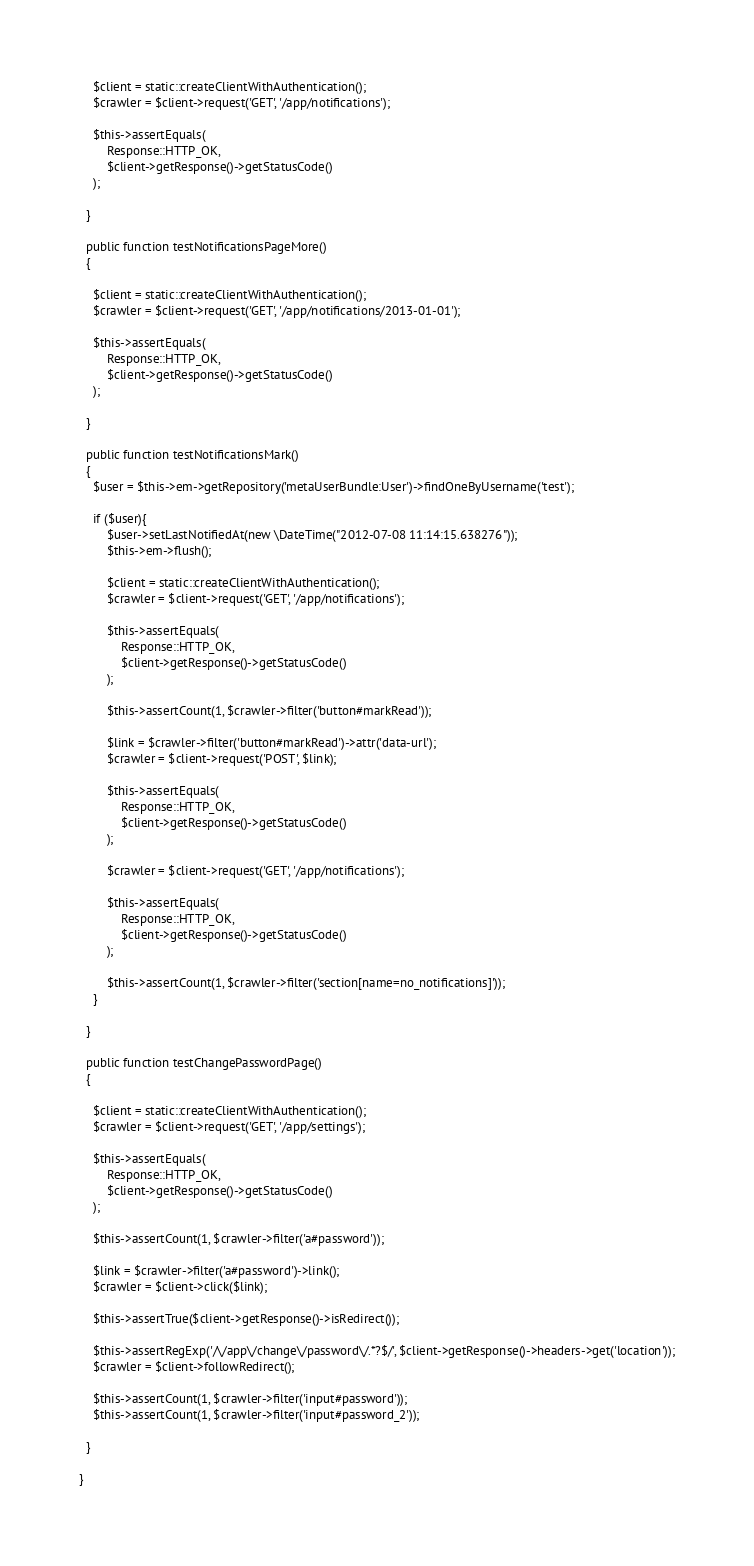<code> <loc_0><loc_0><loc_500><loc_500><_PHP_>
    $client = static::createClientWithAuthentication();
    $crawler = $client->request('GET', '/app/notifications');

    $this->assertEquals(
        Response::HTTP_OK,
        $client->getResponse()->getStatusCode()
    );
    
  }

  public function testNotificationsPageMore()
  {
   
    $client = static::createClientWithAuthentication();
    $crawler = $client->request('GET', '/app/notifications/2013-01-01');

    $this->assertEquals(
        Response::HTTP_OK,
        $client->getResponse()->getStatusCode()
    );

  }

  public function testNotificationsMark()
  {
    $user = $this->em->getRepository('metaUserBundle:User')->findOneByUsername('test');

    if ($user){
        $user->setLastNotifiedAt(new \DateTime("2012-07-08 11:14:15.638276"));
        $this->em->flush();

        $client = static::createClientWithAuthentication();
        $crawler = $client->request('GET', '/app/notifications');

        $this->assertEquals(
            Response::HTTP_OK,
            $client->getResponse()->getStatusCode()
        );
    
        $this->assertCount(1, $crawler->filter('button#markRead'));

        $link = $crawler->filter('button#markRead')->attr('data-url');
        $crawler = $client->request('POST', $link);

        $this->assertEquals(
            Response::HTTP_OK,
            $client->getResponse()->getStatusCode()
        );
    
        $crawler = $client->request('GET', '/app/notifications');

        $this->assertEquals(
            Response::HTTP_OK,
            $client->getResponse()->getStatusCode()
        );
    
        $this->assertCount(1, $crawler->filter('section[name=no_notifications]'));
    }

  }

  public function testChangePasswordPage()
  {

    $client = static::createClientWithAuthentication();
    $crawler = $client->request('GET', '/app/settings');

    $this->assertEquals(
        Response::HTTP_OK,
        $client->getResponse()->getStatusCode()
    );

    $this->assertCount(1, $crawler->filter('a#password'));

    $link = $crawler->filter('a#password')->link();
    $crawler = $client->click($link);

    $this->assertTrue($client->getResponse()->isRedirect());

    $this->assertRegExp('/\/app\/change\/password\/.*?$/', $client->getResponse()->headers->get('location'));
    $crawler = $client->followRedirect();

    $this->assertCount(1, $crawler->filter('input#password'));
    $this->assertCount(1, $crawler->filter('input#password_2'));

  }

}
</code> 